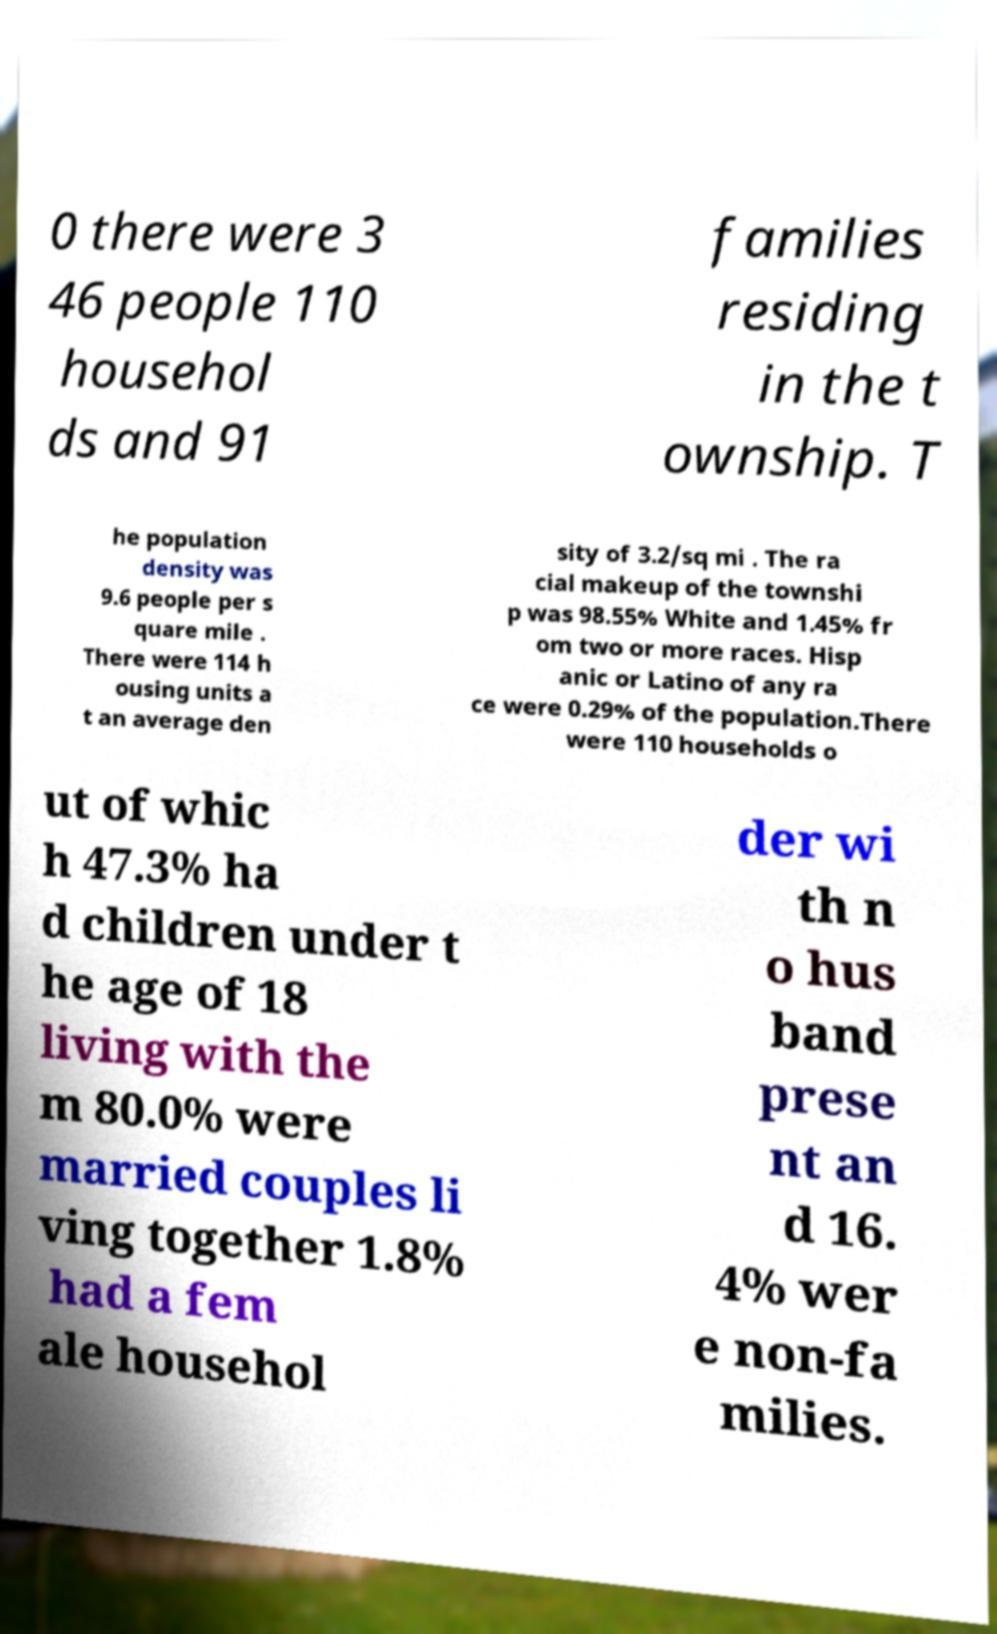Could you extract and type out the text from this image? 0 there were 3 46 people 110 househol ds and 91 families residing in the t ownship. T he population density was 9.6 people per s quare mile . There were 114 h ousing units a t an average den sity of 3.2/sq mi . The ra cial makeup of the townshi p was 98.55% White and 1.45% fr om two or more races. Hisp anic or Latino of any ra ce were 0.29% of the population.There were 110 households o ut of whic h 47.3% ha d children under t he age of 18 living with the m 80.0% were married couples li ving together 1.8% had a fem ale househol der wi th n o hus band prese nt an d 16. 4% wer e non-fa milies. 